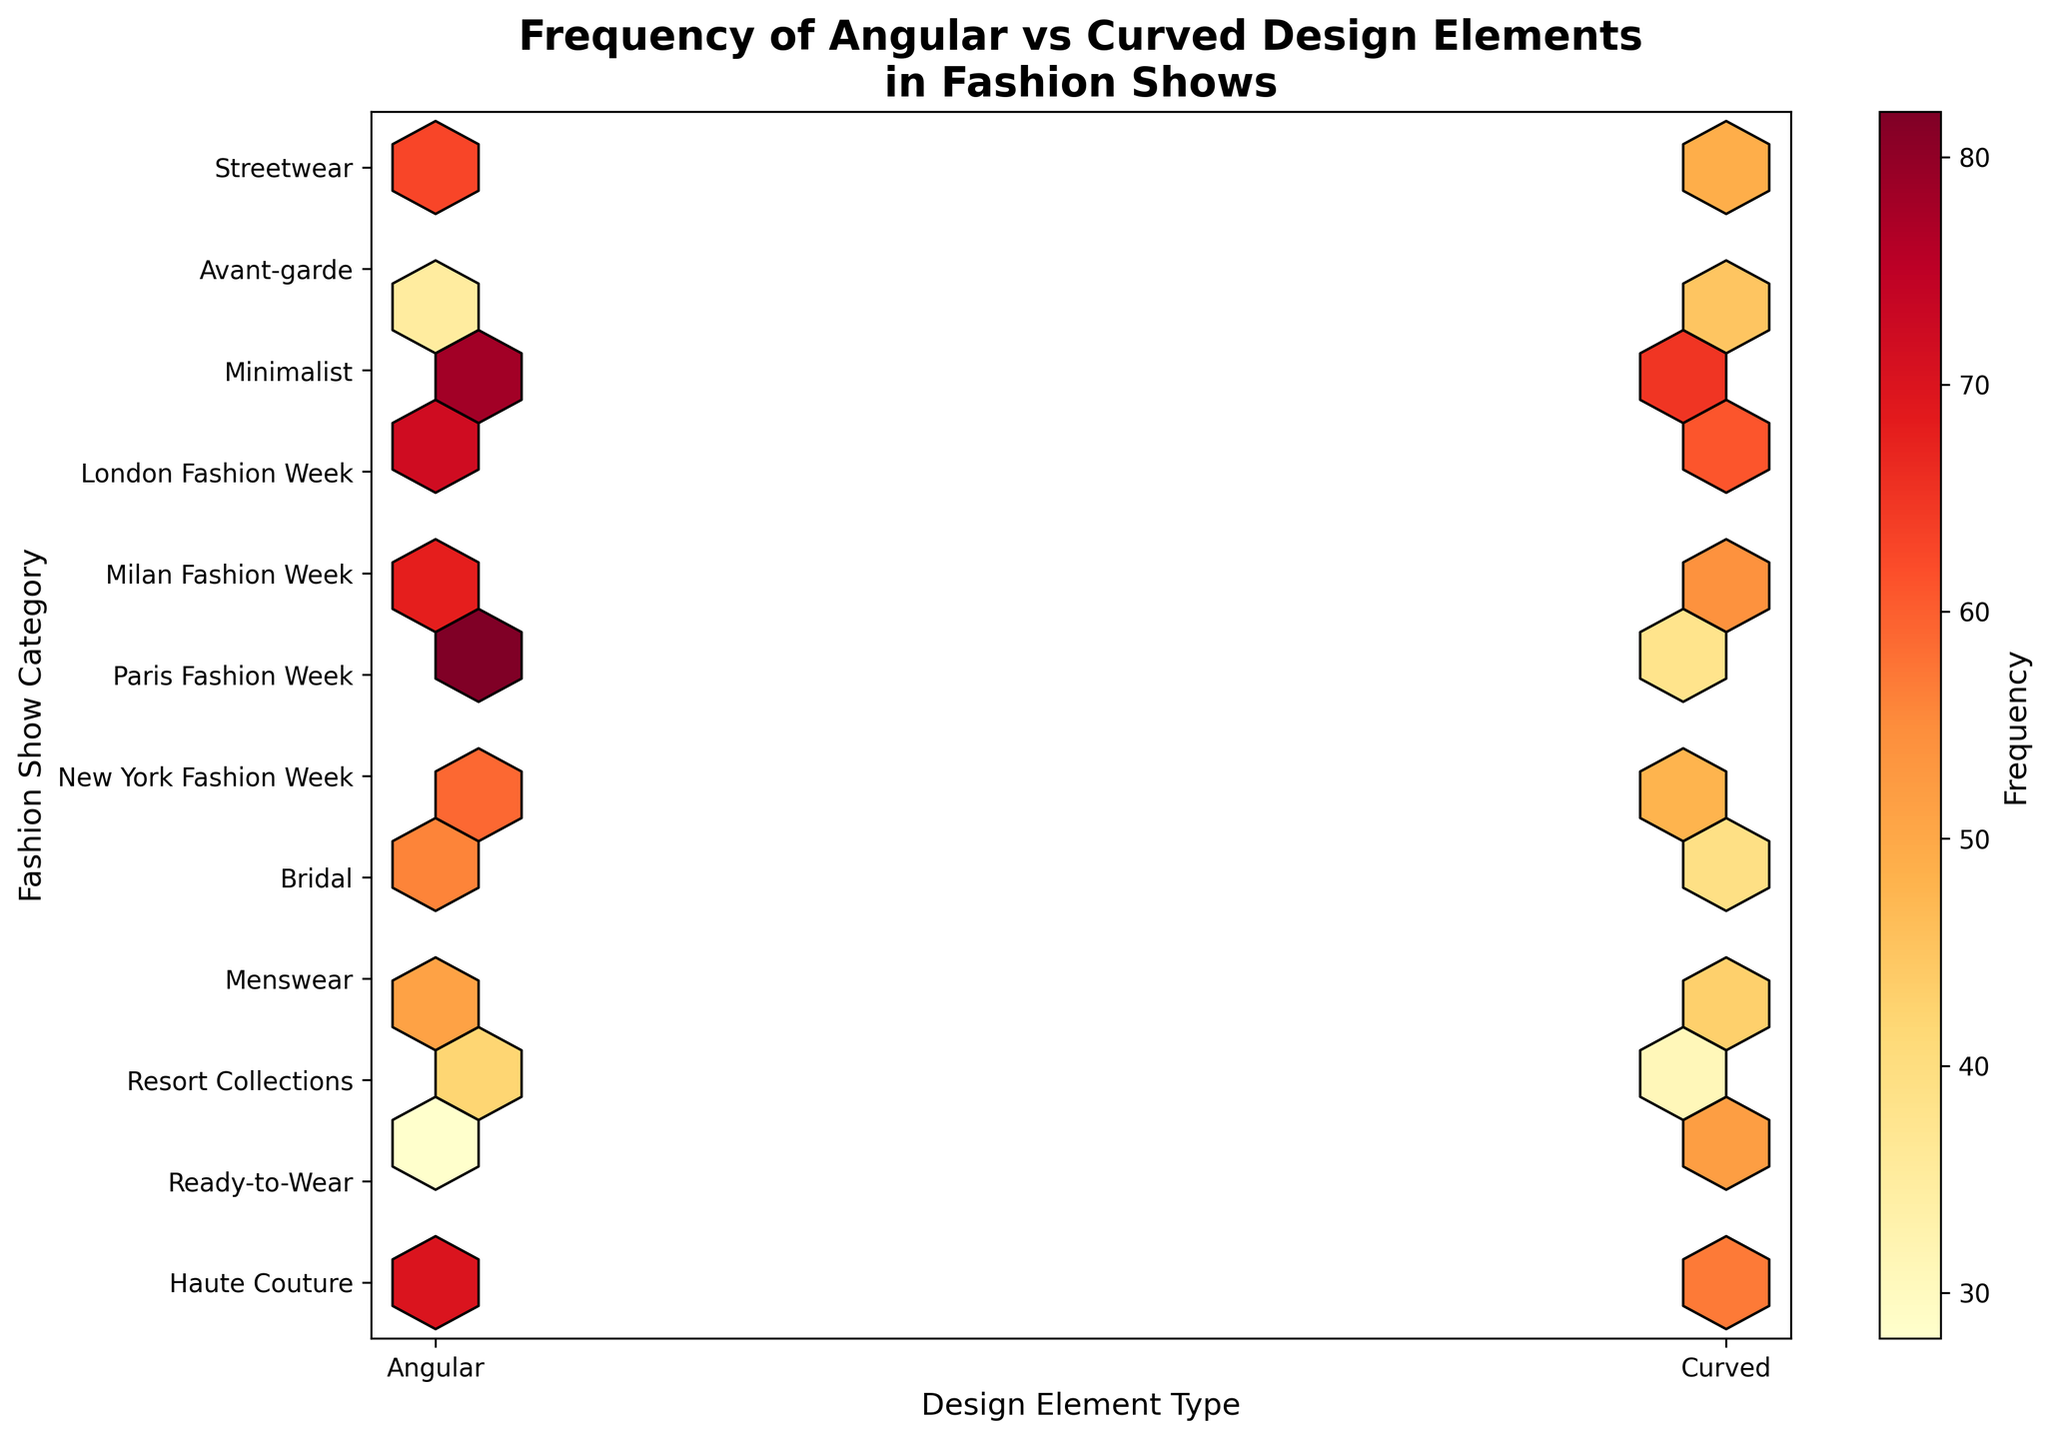What is the title of the plot? The title of the plot is located at the top of the figure, and it provides a summary of what the plot represents. Here, it reads "Frequency of Angular vs Curved Design Elements in Fashion Shows."
Answer: Frequency of Angular vs Curved Design Elements in Fashion Shows Which design element type has more instances overall, Angular or Curved? By observing the hexbin plot, one can compare the overall density and color intensity for Angular and Curved elements. Angular elements tend to show more orange and red areas, indicating higher frequencies.
Answer: Angular How many categories are represented on the y-axis? The y-axis shows the categories of fashion shows. By counting the ticks and labels on the y-axis, one can determine the number of distinct categories.
Answer: 9 Which category has the highest frequency for Angular elements? To find this, look for the cell in the hexbin plot that has the highest color intensity in the Angular column. The categories are labeled on the y-axis.
Answer: Minimalist What is the frequency of Curved design elements in the Bridal category? Locate the position corresponding to the "Curved" type on the x-axis and "Bridal" category on the y-axis, then read the color intensity and cross-reference with the color bar to find the frequency.
Answer: 52 Is there any category where the frequency of Angular and Curved design elements are equal? Check the plot for any rows where the colors of the cells for Angular and Curved elements match exactly, which would indicate equal frequencies.
Answer: No Which fashion week has the highest frequency for Curved design elements? Look at the segments corresponding to the various fashion weeks on the y-axis for Curved elements, and identify the one with the most intense color.
Answer: Paris Fashion Week What is the average frequency of Angular elements across all categories? Sum the frequencies of Angular elements in all categories and divide by the number of categories (which is 9).
Answer: (42+78+35+56+28+68+72+59+51+82+70+63)/9 = 67.56 Comparing Haute Couture and Bridal categories, which has a higher frequency for Curved elements, and by how much? Compare the frequencies of Curved elements in the Haute Couture and Bridal categories. The difference is calculated by subtracting the smaller frequency from the larger one.
Answer: Bridal has a higher frequency by 21 (52 - 31) Which design element type is more frequent in Menswear? Compare the color intensities for Menswear in both Angular and Curved columns to determine the more frequent design element type.
Answer: Angular 